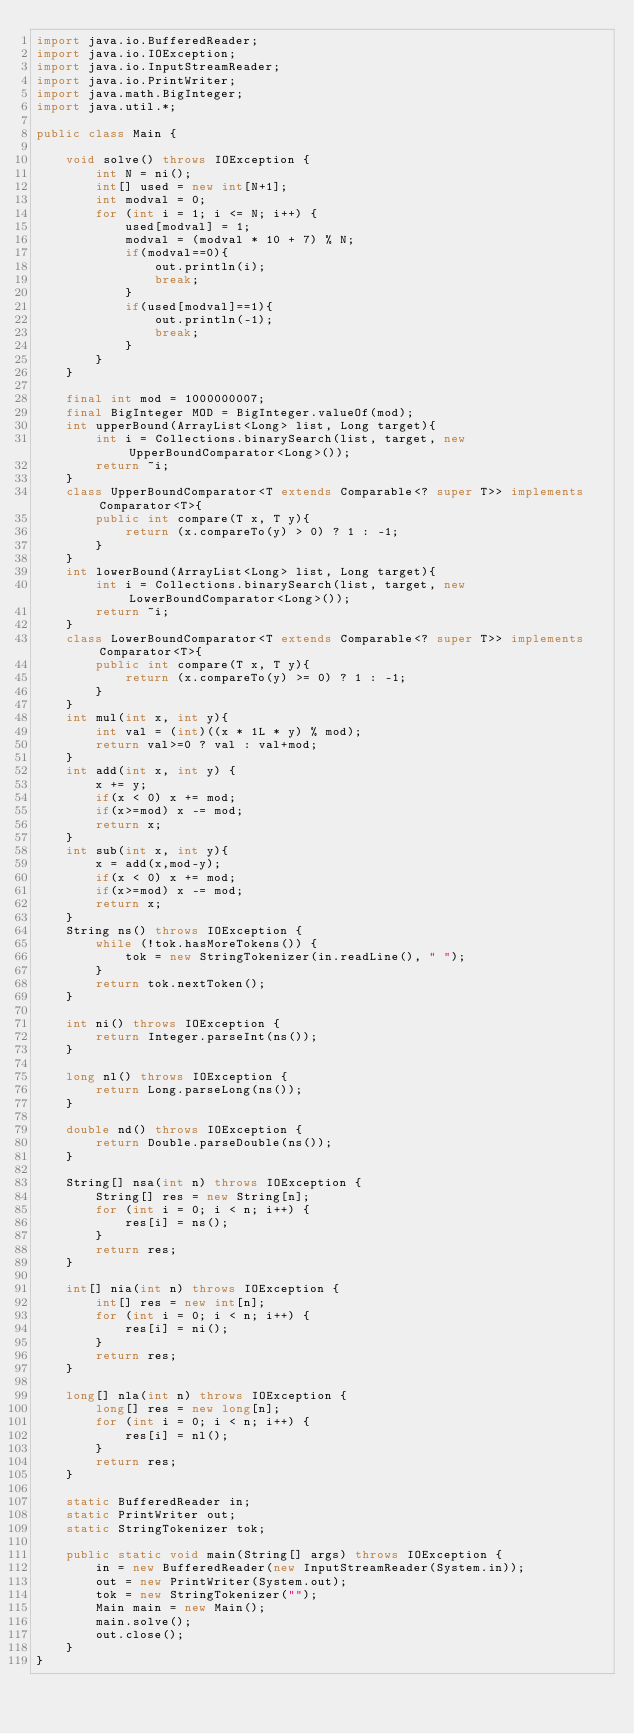Convert code to text. <code><loc_0><loc_0><loc_500><loc_500><_Java_>import java.io.BufferedReader;
import java.io.IOException;
import java.io.InputStreamReader;
import java.io.PrintWriter;
import java.math.BigInteger;
import java.util.*;
 
public class Main {
 
    void solve() throws IOException {
        int N = ni();
        int[] used = new int[N+1];
        int modval = 0;
        for (int i = 1; i <= N; i++) {
            used[modval] = 1;
            modval = (modval * 10 + 7) % N;
            if(modval==0){
                out.println(i);
                break;
            }
            if(used[modval]==1){
                out.println(-1);
                break;
            }
        }
    }

    final int mod = 1000000007;
    final BigInteger MOD = BigInteger.valueOf(mod);
    int upperBound(ArrayList<Long> list, Long target){
        int i = Collections.binarySearch(list, target, new UpperBoundComparator<Long>());
        return ~i;
    }
    class UpperBoundComparator<T extends Comparable<? super T>> implements Comparator<T>{
        public int compare(T x, T y){
            return (x.compareTo(y) > 0) ? 1 : -1;
        }
    }
    int lowerBound(ArrayList<Long> list, Long target){
        int i = Collections.binarySearch(list, target, new LowerBoundComparator<Long>());
        return ~i;
    }
    class LowerBoundComparator<T extends Comparable<? super T>> implements Comparator<T>{
        public int compare(T x, T y){
            return (x.compareTo(y) >= 0) ? 1 : -1;
        }
    }
    int mul(int x, int y){
        int val = (int)((x * 1L * y) % mod);
        return val>=0 ? val : val+mod;
    }
    int add(int x, int y) {
        x += y;
        if(x < 0) x += mod;
        if(x>=mod) x -= mod;
        return x;
    }
    int sub(int x, int y){
        x = add(x,mod-y);
        if(x < 0) x += mod;
        if(x>=mod) x -= mod;
        return x;
    }
    String ns() throws IOException {
        while (!tok.hasMoreTokens()) {
            tok = new StringTokenizer(in.readLine(), " ");
        }
        return tok.nextToken();
    }
 
    int ni() throws IOException {
        return Integer.parseInt(ns());
    }
 
    long nl() throws IOException {
        return Long.parseLong(ns());
    }
 
    double nd() throws IOException {
        return Double.parseDouble(ns());
    }
 
    String[] nsa(int n) throws IOException {
        String[] res = new String[n];
        for (int i = 0; i < n; i++) {
            res[i] = ns();
        }
        return res;
    }
 
    int[] nia(int n) throws IOException {
        int[] res = new int[n];
        for (int i = 0; i < n; i++) {
            res[i] = ni();
        }
        return res;
    }
 
    long[] nla(int n) throws IOException {
        long[] res = new long[n];
        for (int i = 0; i < n; i++) {
            res[i] = nl();
        }
        return res;
    }
 
    static BufferedReader in;
    static PrintWriter out;
    static StringTokenizer tok;
 
    public static void main(String[] args) throws IOException {
        in = new BufferedReader(new InputStreamReader(System.in));
        out = new PrintWriter(System.out);
        tok = new StringTokenizer("");
        Main main = new Main();
        main.solve();
        out.close();
    }
}</code> 